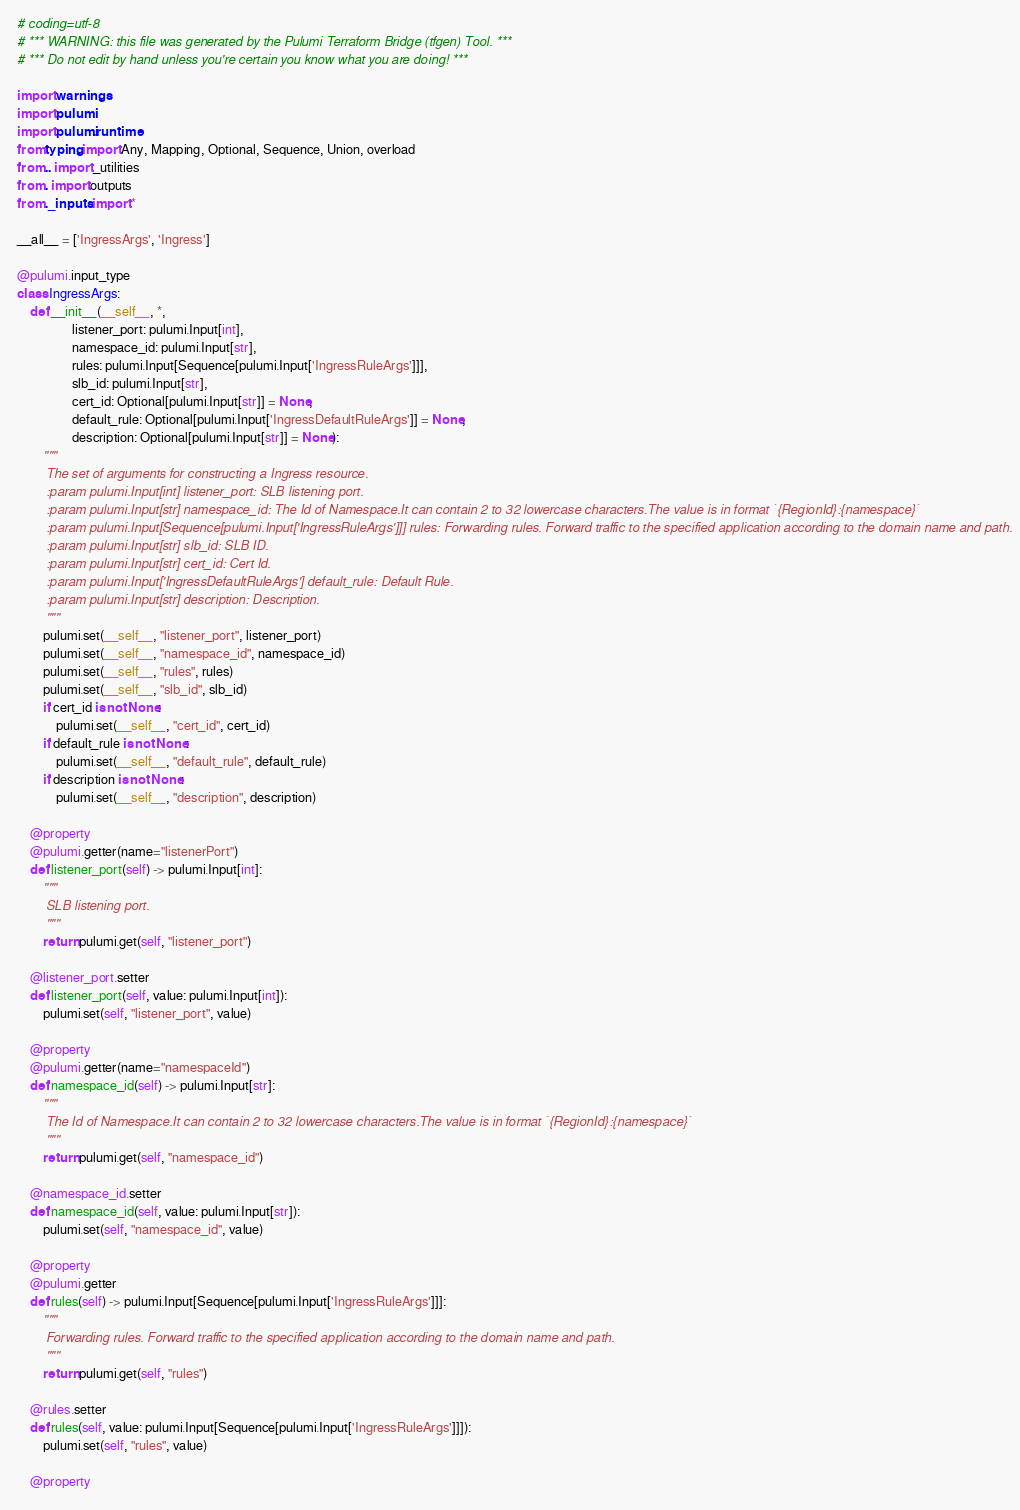Convert code to text. <code><loc_0><loc_0><loc_500><loc_500><_Python_># coding=utf-8
# *** WARNING: this file was generated by the Pulumi Terraform Bridge (tfgen) Tool. ***
# *** Do not edit by hand unless you're certain you know what you are doing! ***

import warnings
import pulumi
import pulumi.runtime
from typing import Any, Mapping, Optional, Sequence, Union, overload
from .. import _utilities
from . import outputs
from ._inputs import *

__all__ = ['IngressArgs', 'Ingress']

@pulumi.input_type
class IngressArgs:
    def __init__(__self__, *,
                 listener_port: pulumi.Input[int],
                 namespace_id: pulumi.Input[str],
                 rules: pulumi.Input[Sequence[pulumi.Input['IngressRuleArgs']]],
                 slb_id: pulumi.Input[str],
                 cert_id: Optional[pulumi.Input[str]] = None,
                 default_rule: Optional[pulumi.Input['IngressDefaultRuleArgs']] = None,
                 description: Optional[pulumi.Input[str]] = None):
        """
        The set of arguments for constructing a Ingress resource.
        :param pulumi.Input[int] listener_port: SLB listening port.
        :param pulumi.Input[str] namespace_id: The Id of Namespace.It can contain 2 to 32 lowercase characters.The value is in format `{RegionId}:{namespace}`
        :param pulumi.Input[Sequence[pulumi.Input['IngressRuleArgs']]] rules: Forwarding rules. Forward traffic to the specified application according to the domain name and path.
        :param pulumi.Input[str] slb_id: SLB ID.
        :param pulumi.Input[str] cert_id: Cert Id.
        :param pulumi.Input['IngressDefaultRuleArgs'] default_rule: Default Rule.
        :param pulumi.Input[str] description: Description.
        """
        pulumi.set(__self__, "listener_port", listener_port)
        pulumi.set(__self__, "namespace_id", namespace_id)
        pulumi.set(__self__, "rules", rules)
        pulumi.set(__self__, "slb_id", slb_id)
        if cert_id is not None:
            pulumi.set(__self__, "cert_id", cert_id)
        if default_rule is not None:
            pulumi.set(__self__, "default_rule", default_rule)
        if description is not None:
            pulumi.set(__self__, "description", description)

    @property
    @pulumi.getter(name="listenerPort")
    def listener_port(self) -> pulumi.Input[int]:
        """
        SLB listening port.
        """
        return pulumi.get(self, "listener_port")

    @listener_port.setter
    def listener_port(self, value: pulumi.Input[int]):
        pulumi.set(self, "listener_port", value)

    @property
    @pulumi.getter(name="namespaceId")
    def namespace_id(self) -> pulumi.Input[str]:
        """
        The Id of Namespace.It can contain 2 to 32 lowercase characters.The value is in format `{RegionId}:{namespace}`
        """
        return pulumi.get(self, "namespace_id")

    @namespace_id.setter
    def namespace_id(self, value: pulumi.Input[str]):
        pulumi.set(self, "namespace_id", value)

    @property
    @pulumi.getter
    def rules(self) -> pulumi.Input[Sequence[pulumi.Input['IngressRuleArgs']]]:
        """
        Forwarding rules. Forward traffic to the specified application according to the domain name and path.
        """
        return pulumi.get(self, "rules")

    @rules.setter
    def rules(self, value: pulumi.Input[Sequence[pulumi.Input['IngressRuleArgs']]]):
        pulumi.set(self, "rules", value)

    @property</code> 